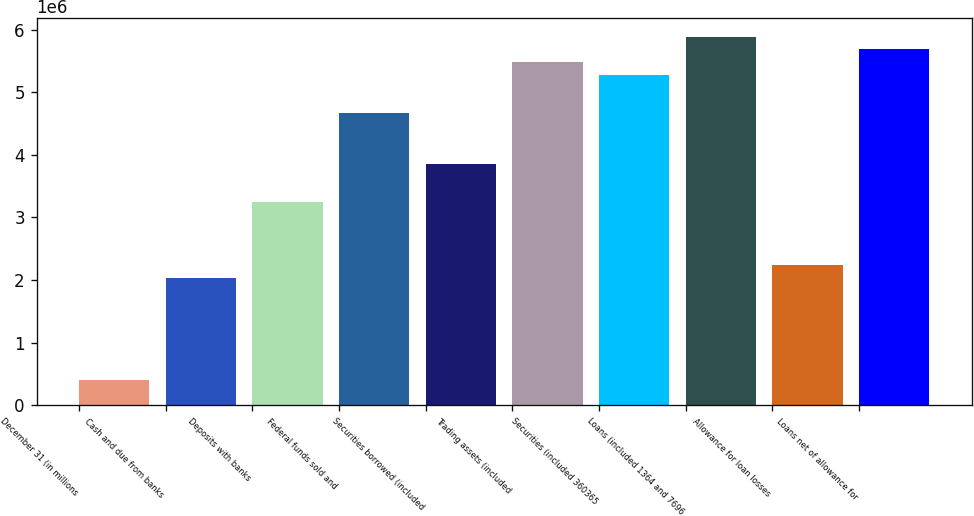Convert chart. <chart><loc_0><loc_0><loc_500><loc_500><bar_chart><fcel>December 31 (in millions<fcel>Cash and due from banks<fcel>Deposits with banks<fcel>Federal funds sold and<fcel>Securities borrowed (included<fcel>Trading assets (included<fcel>Securities (included 360365<fcel>Loans (included 1364 and 7696<fcel>Allowance for loan losses<fcel>Loans net of allowance for<nl><fcel>406452<fcel>2.03199e+06<fcel>3.25114e+06<fcel>4.67349e+06<fcel>3.86072e+06<fcel>5.48625e+06<fcel>5.28306e+06<fcel>5.89264e+06<fcel>2.23518e+06<fcel>5.68945e+06<nl></chart> 